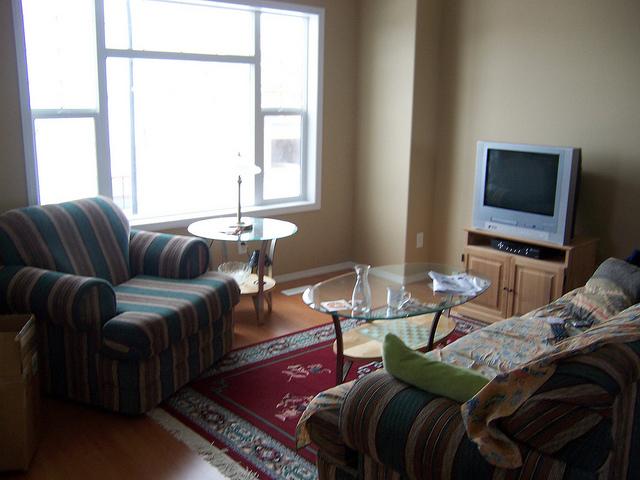Is there a cover on the couch?
Keep it brief. Yes. What is the table made of?
Short answer required. Glass. What color is the couch?
Answer briefly. Blue and red. Is the television on?
Quick response, please. No. Is this a wooden chair?
Write a very short answer. No. 